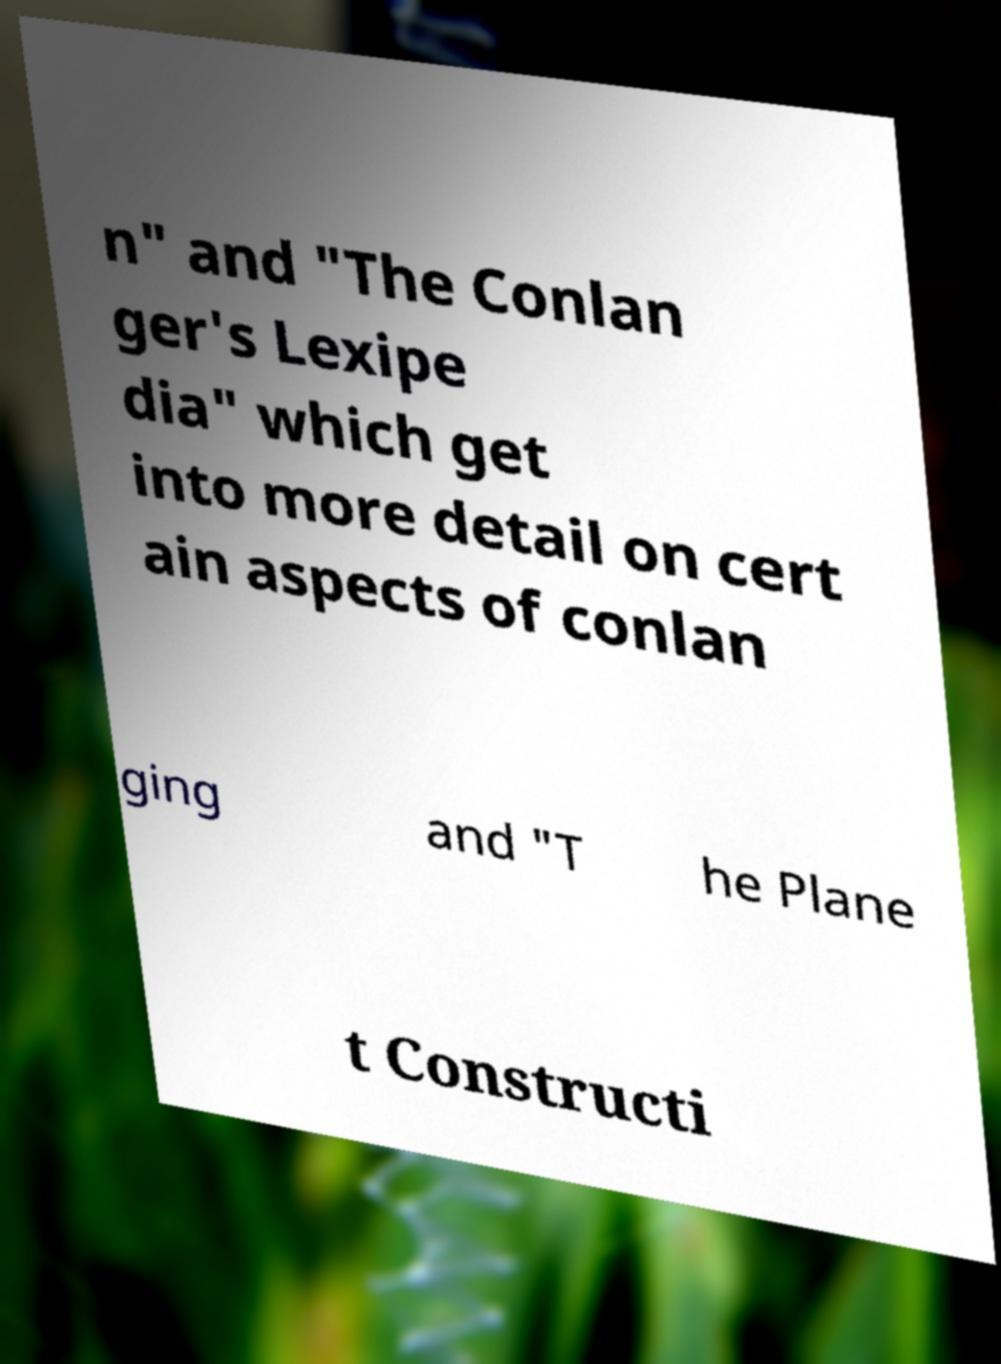There's text embedded in this image that I need extracted. Can you transcribe it verbatim? n" and "The Conlan ger's Lexipe dia" which get into more detail on cert ain aspects of conlan ging and "T he Plane t Constructi 